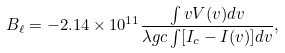Convert formula to latex. <formula><loc_0><loc_0><loc_500><loc_500>B _ { \ell } = - 2 . 1 4 \times 1 0 ^ { 1 1 } \frac { \int v V ( v ) d v } { \lambda g c \int [ I _ { c } - I ( v ) ] d v } ,</formula> 